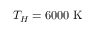Convert formula to latex. <formula><loc_0><loc_0><loc_500><loc_500>T _ { H } = 6 0 0 0 \ K</formula> 